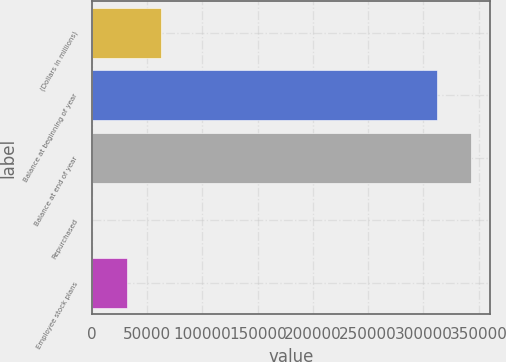Convert chart. <chart><loc_0><loc_0><loc_500><loc_500><bar_chart><fcel>(Dollars in millions)<fcel>Balance at beginning of year<fcel>Balance at end of year<fcel>Repurchased<fcel>Employee stock plans<nl><fcel>62670.8<fcel>312166<fcel>343353<fcel>297<fcel>31483.9<nl></chart> 